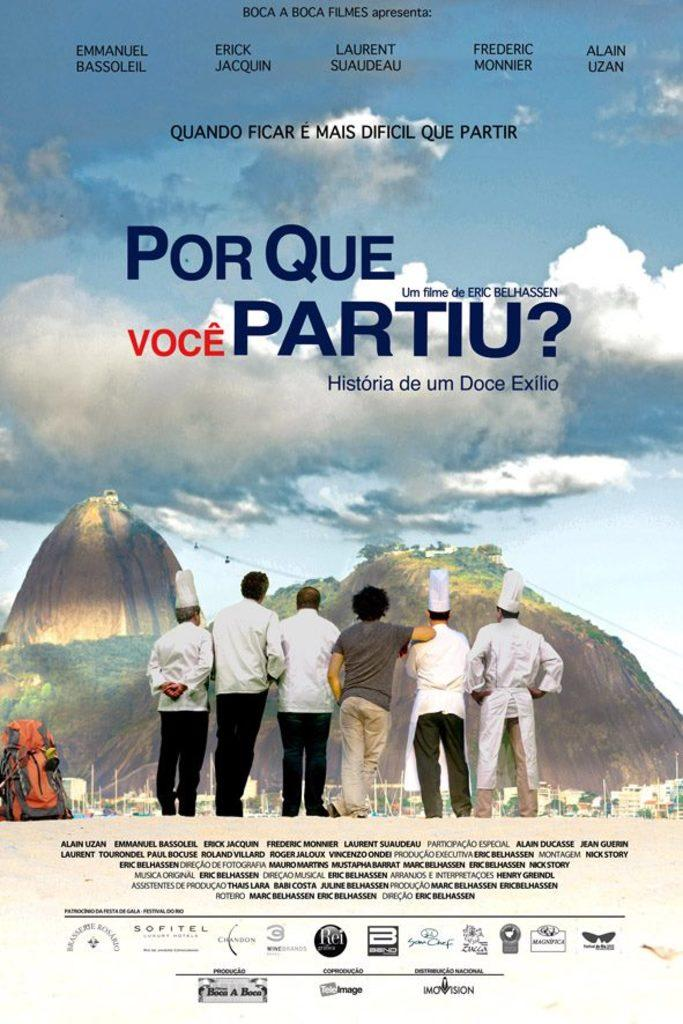Provide a one-sentence caption for the provided image. poster for the film Por Que Voce partiu with six different men on the bottom. 